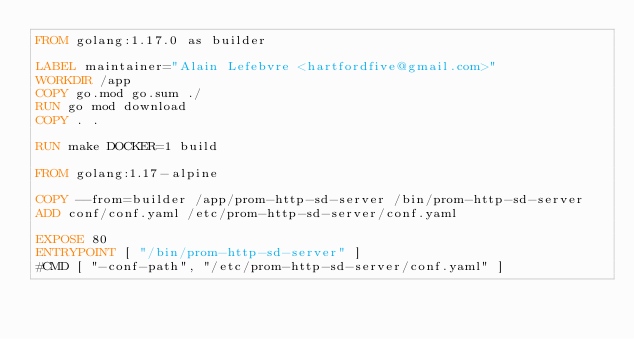Convert code to text. <code><loc_0><loc_0><loc_500><loc_500><_Dockerfile_>FROM golang:1.17.0 as builder

LABEL maintainer="Alain Lefebvre <hartfordfive@gmail.com>"
WORKDIR /app
COPY go.mod go.sum ./
RUN go mod download
COPY . .

RUN make DOCKER=1 build

FROM golang:1.17-alpine 

COPY --from=builder /app/prom-http-sd-server /bin/prom-http-sd-server
ADD conf/conf.yaml /etc/prom-http-sd-server/conf.yaml

EXPOSE 80
ENTRYPOINT [ "/bin/prom-http-sd-server" ]
#CMD [ "-conf-path", "/etc/prom-http-sd-server/conf.yaml" ]
</code> 